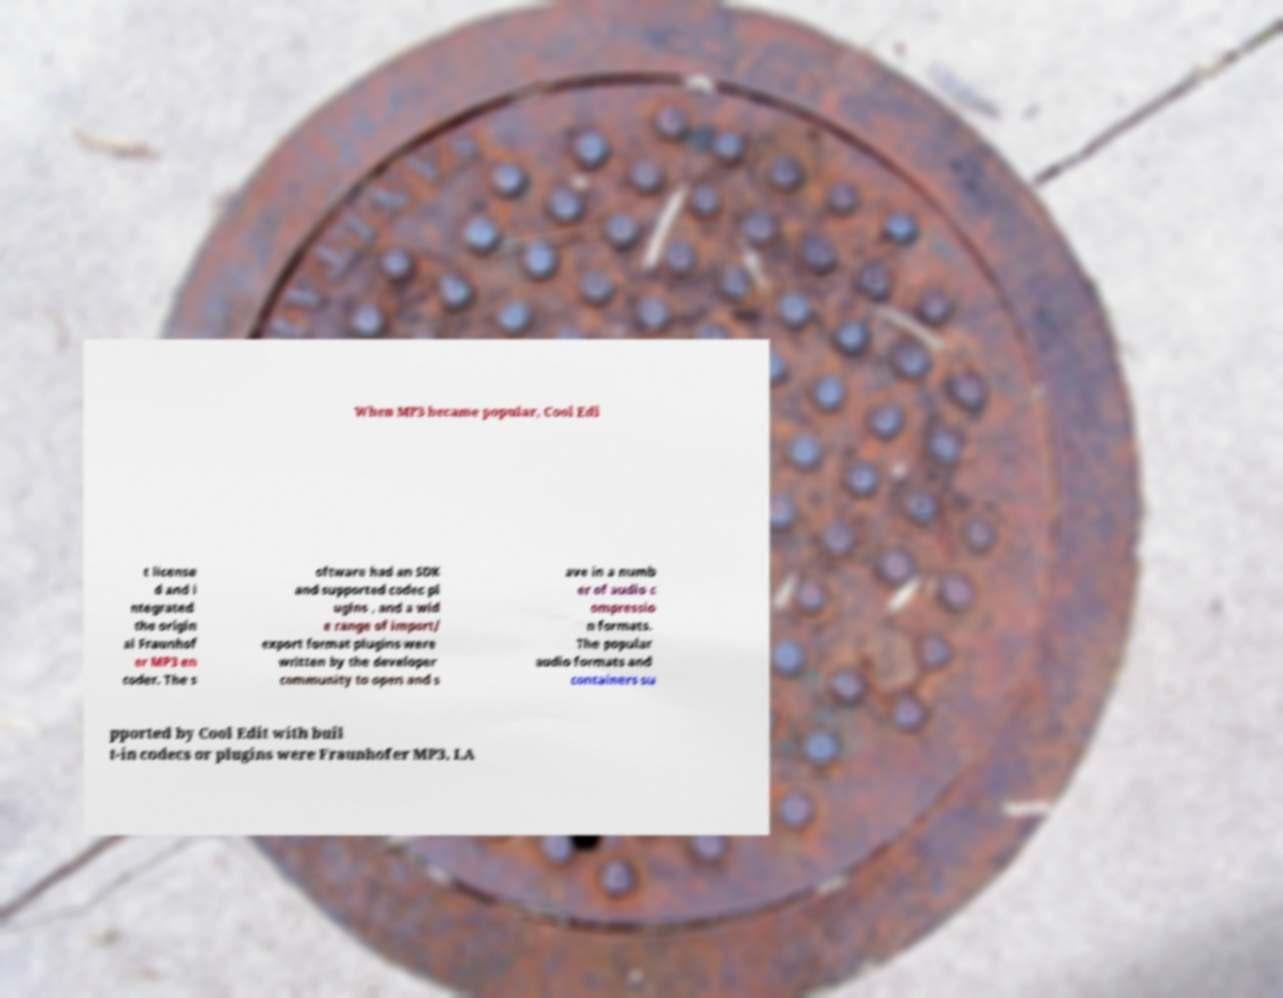There's text embedded in this image that I need extracted. Can you transcribe it verbatim? When MP3 became popular, Cool Edi t license d and i ntegrated the origin al Fraunhof er MP3 en coder. The s oftware had an SDK and supported codec pl ugins , and a wid e range of import/ export format plugins were written by the developer community to open and s ave in a numb er of audio c ompressio n formats. The popular audio formats and containers su pported by Cool Edit with buil t-in codecs or plugins were Fraunhofer MP3, LA 